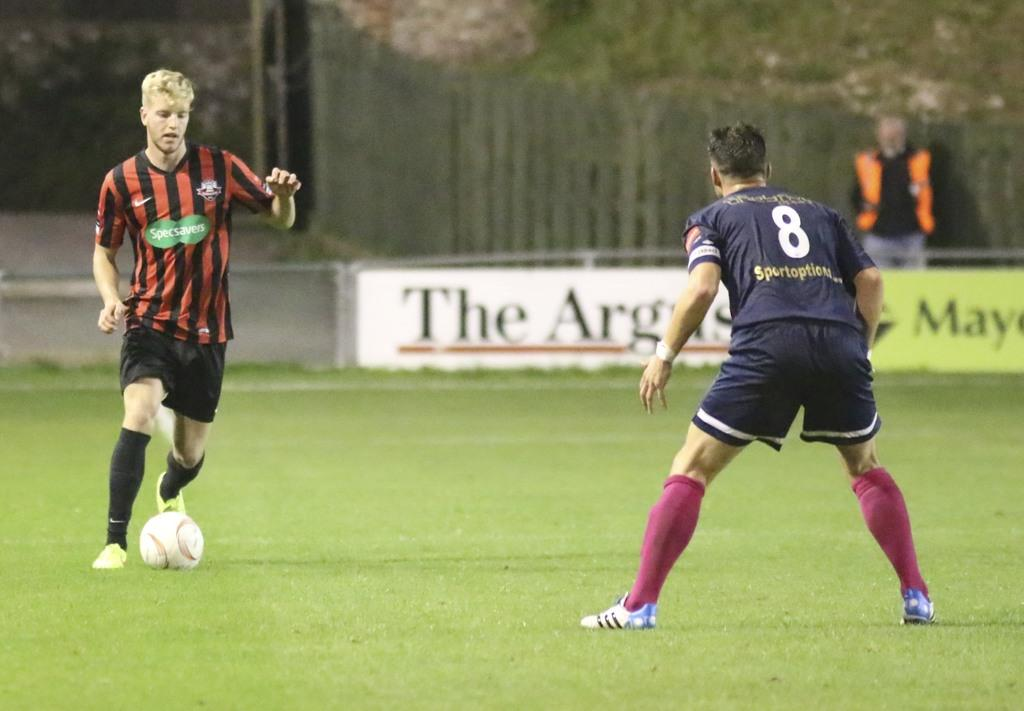<image>
Render a clear and concise summary of the photo. A man in a striped jersey is sponsored by Specsavers. 